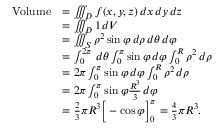Convert formula to latex. <formula><loc_0><loc_0><loc_500><loc_500>{ \begin{array} { r l } { V o l u m e } & { = \iiint _ { D } f ( x , y , z ) \, d x \, d y \, d z } \\ & { = \iiint _ { D } 1 \, d V } \\ & { = \iiint _ { S } \rho ^ { 2 } \sin \varphi \, d \rho \, d \theta \, d \varphi } \\ & { = \int _ { 0 } ^ { 2 \pi } \, d \theta \int _ { 0 } ^ { \pi } \sin \varphi \, d \varphi \int _ { 0 } ^ { R } \rho ^ { 2 } \, d \rho } \\ & { = 2 \pi \int _ { 0 } ^ { \pi } \sin \varphi \, d \varphi \int _ { 0 } ^ { R } \rho ^ { 2 } \, d \rho } \\ & { = 2 \pi \int _ { 0 } ^ { \pi } \sin \varphi { \frac { R ^ { 3 } } { 3 } } \, d \varphi } \\ & { = { \frac { 2 } { 3 } } \pi R ^ { 3 } { \left [ } - \cos \varphi { \right ] } _ { 0 } ^ { \pi } = { \frac { 4 } { 3 } } \pi R ^ { 3 } . } \end{array} }</formula> 